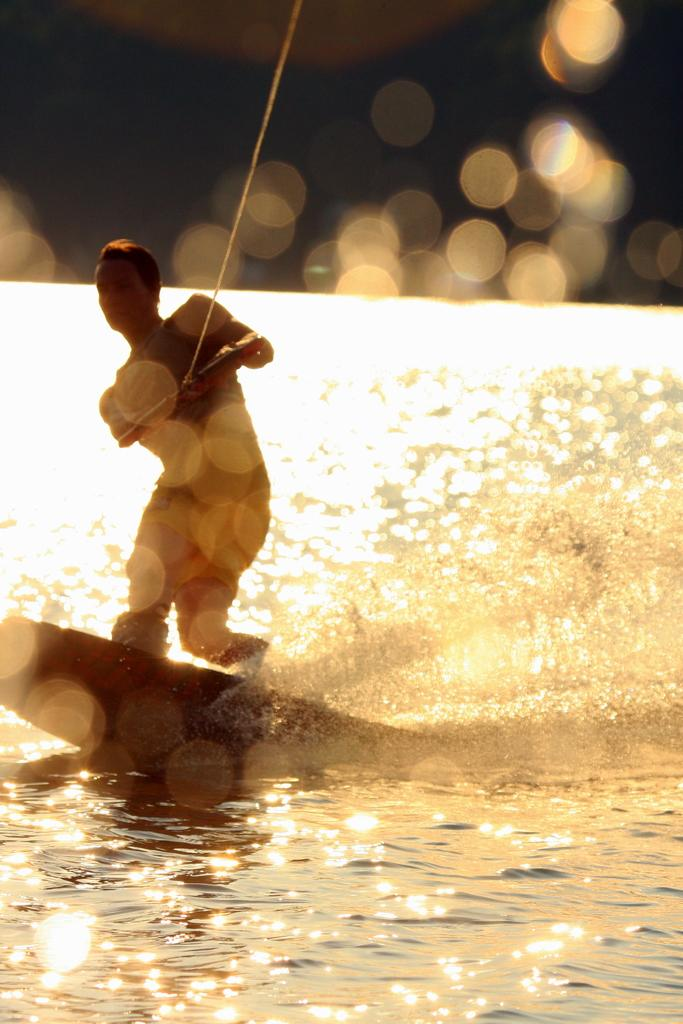What is the main subject of the image? A: There is a person in the image. What is the person holding in the image? The person is holding an object. What is the person standing on in the image? The person is standing on a surfing board. What type of environment is visible in the image? There is water visible at the bottom of the image. What can be seen in the sky in the image? There are lights visible at the top of the image. What type of pancake is the person eating in the image? There is no pancake present in the image, and the person is not eating anything. What book is the person reading while standing on the surfing board? There is no book present in the image, and the person is not reading anything. 